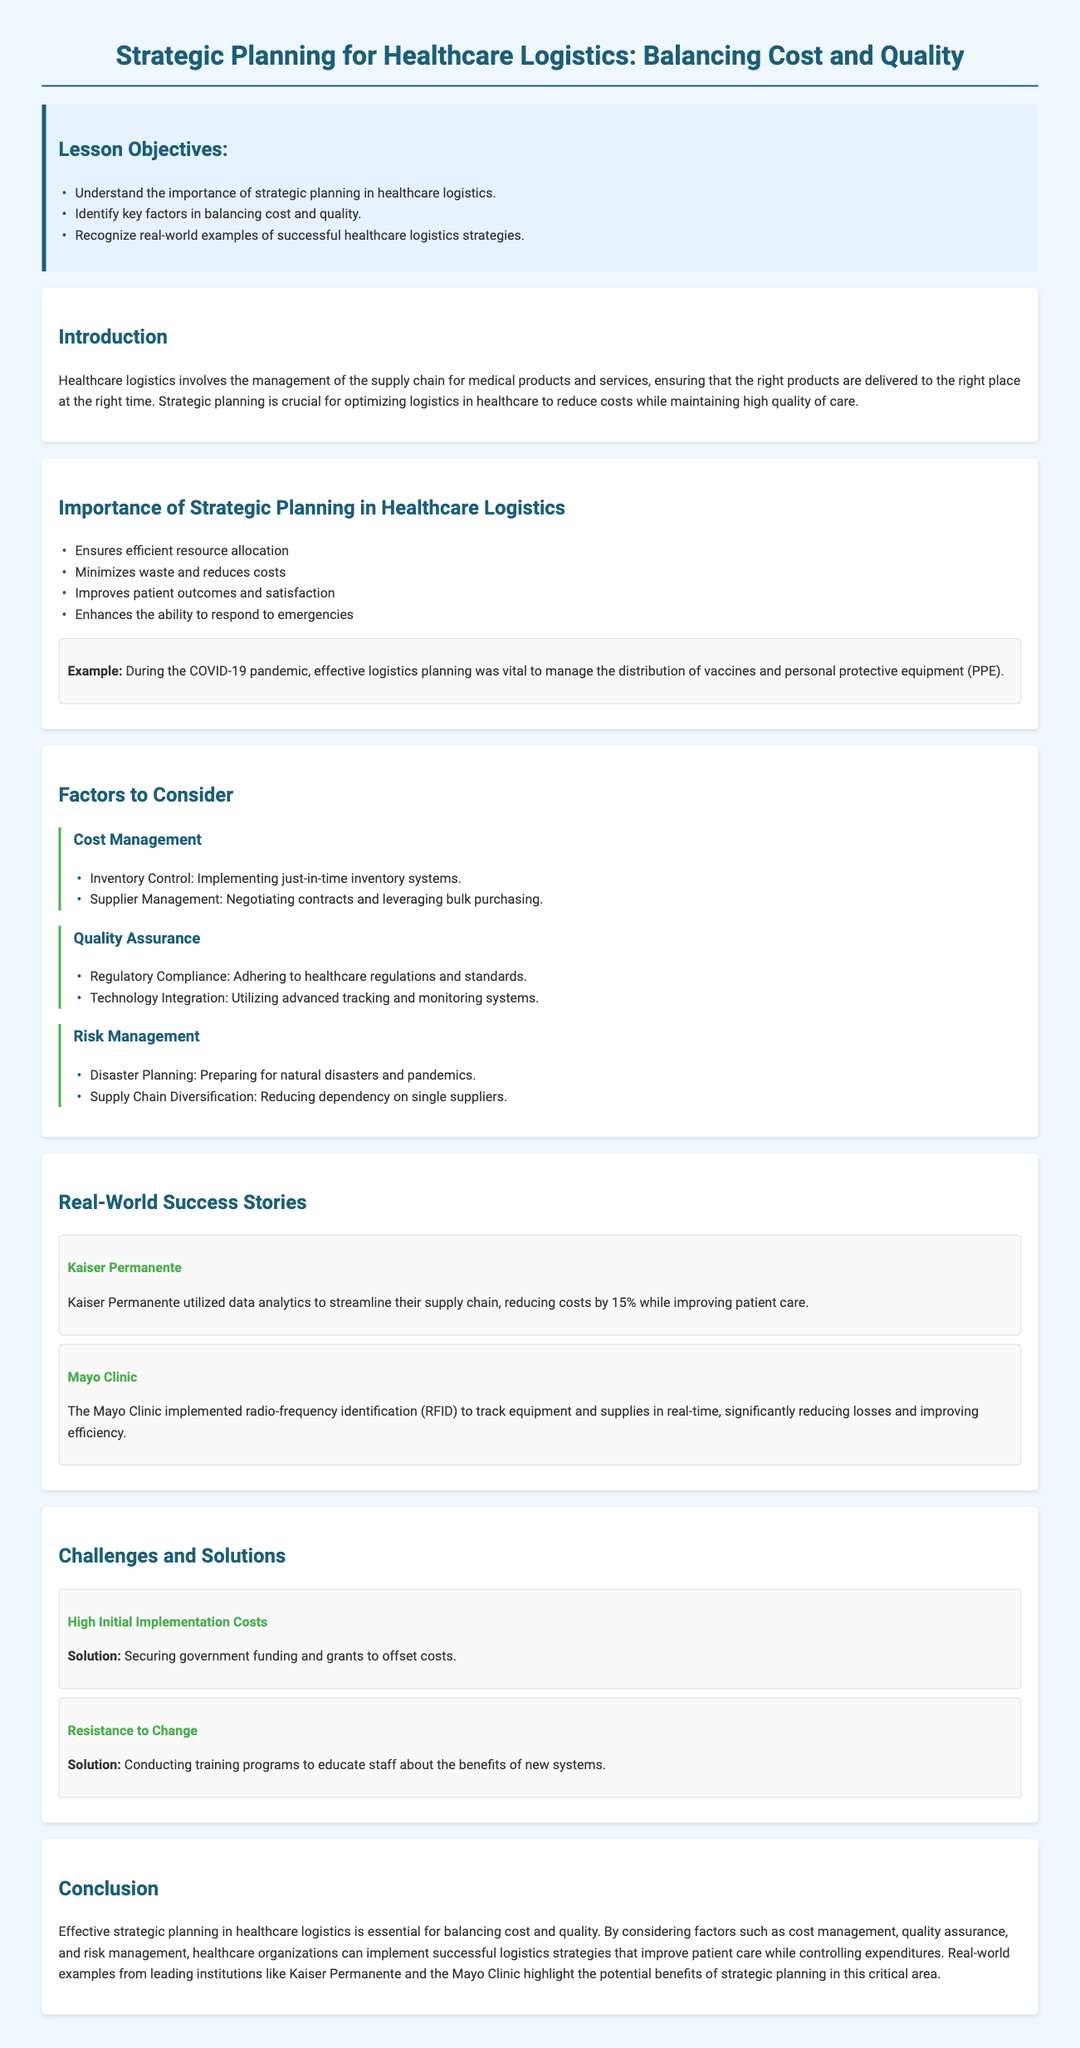What are the lesson objectives? The lesson objectives are listed in the document and include understanding the importance of strategic planning, identifying key factors in balancing cost and quality, and recognizing successful healthcare logistics strategies.
Answer: Understand the importance of strategic planning in healthcare logistics, Identify key factors in balancing cost and quality, Recognize real-world examples of successful healthcare logistics strategies What is the example provided in the Importance of Strategic Planning section? The example demonstrates a real-world scenario related to effective logistics planning during the COVID-19 pandemic.
Answer: During the COVID-19 pandemic, effective logistics planning was vital to manage the distribution of vaccines and personal protective equipment (PPE) Which organization is mentioned as having reduced costs by 15%? The organization that utilized data analytics to streamline their supply chain and achieve cost reduction is mentioned in the Real-World Success Stories section.
Answer: Kaiser Permanente What key factor is related to Regulatory Compliance? The section discussing quality assurance mentions this key factor in relation to adhering to standards within healthcare.
Answer: Quality Assurance What is one challenge in healthcare logistics mentioned in the document? The challenges listed include high initial implementation costs and resistance to change, which are outlined in the Challenges and Solutions section.
Answer: High Initial Implementation Costs What role does strategic planning play in healthcare logistics? The introduction of the document states the significance of strategic planning in the management of logistics.
Answer: Optimizing logistics in healthcare What is a solution for resistance to change? The document suggests a specific approach to counteract resistance to new systems within healthcare logistics.
Answer: Conducting training programs to educate staff about the benefits of new systems 